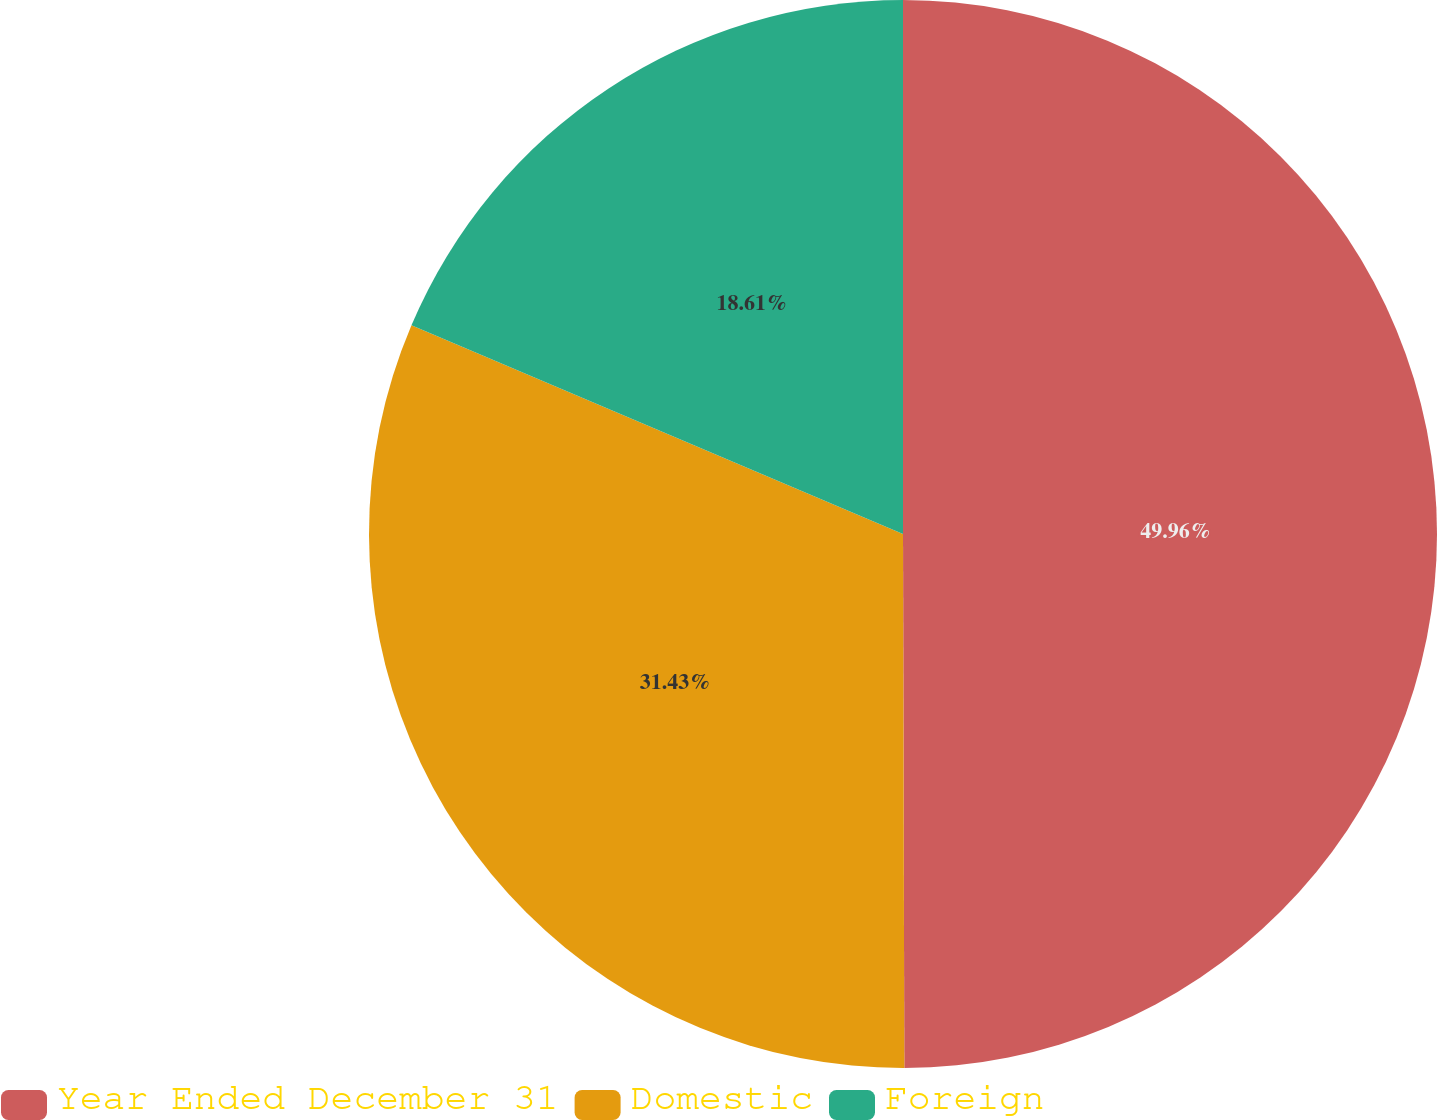Convert chart. <chart><loc_0><loc_0><loc_500><loc_500><pie_chart><fcel>Year Ended December 31<fcel>Domestic<fcel>Foreign<nl><fcel>49.96%<fcel>31.43%<fcel>18.61%<nl></chart> 